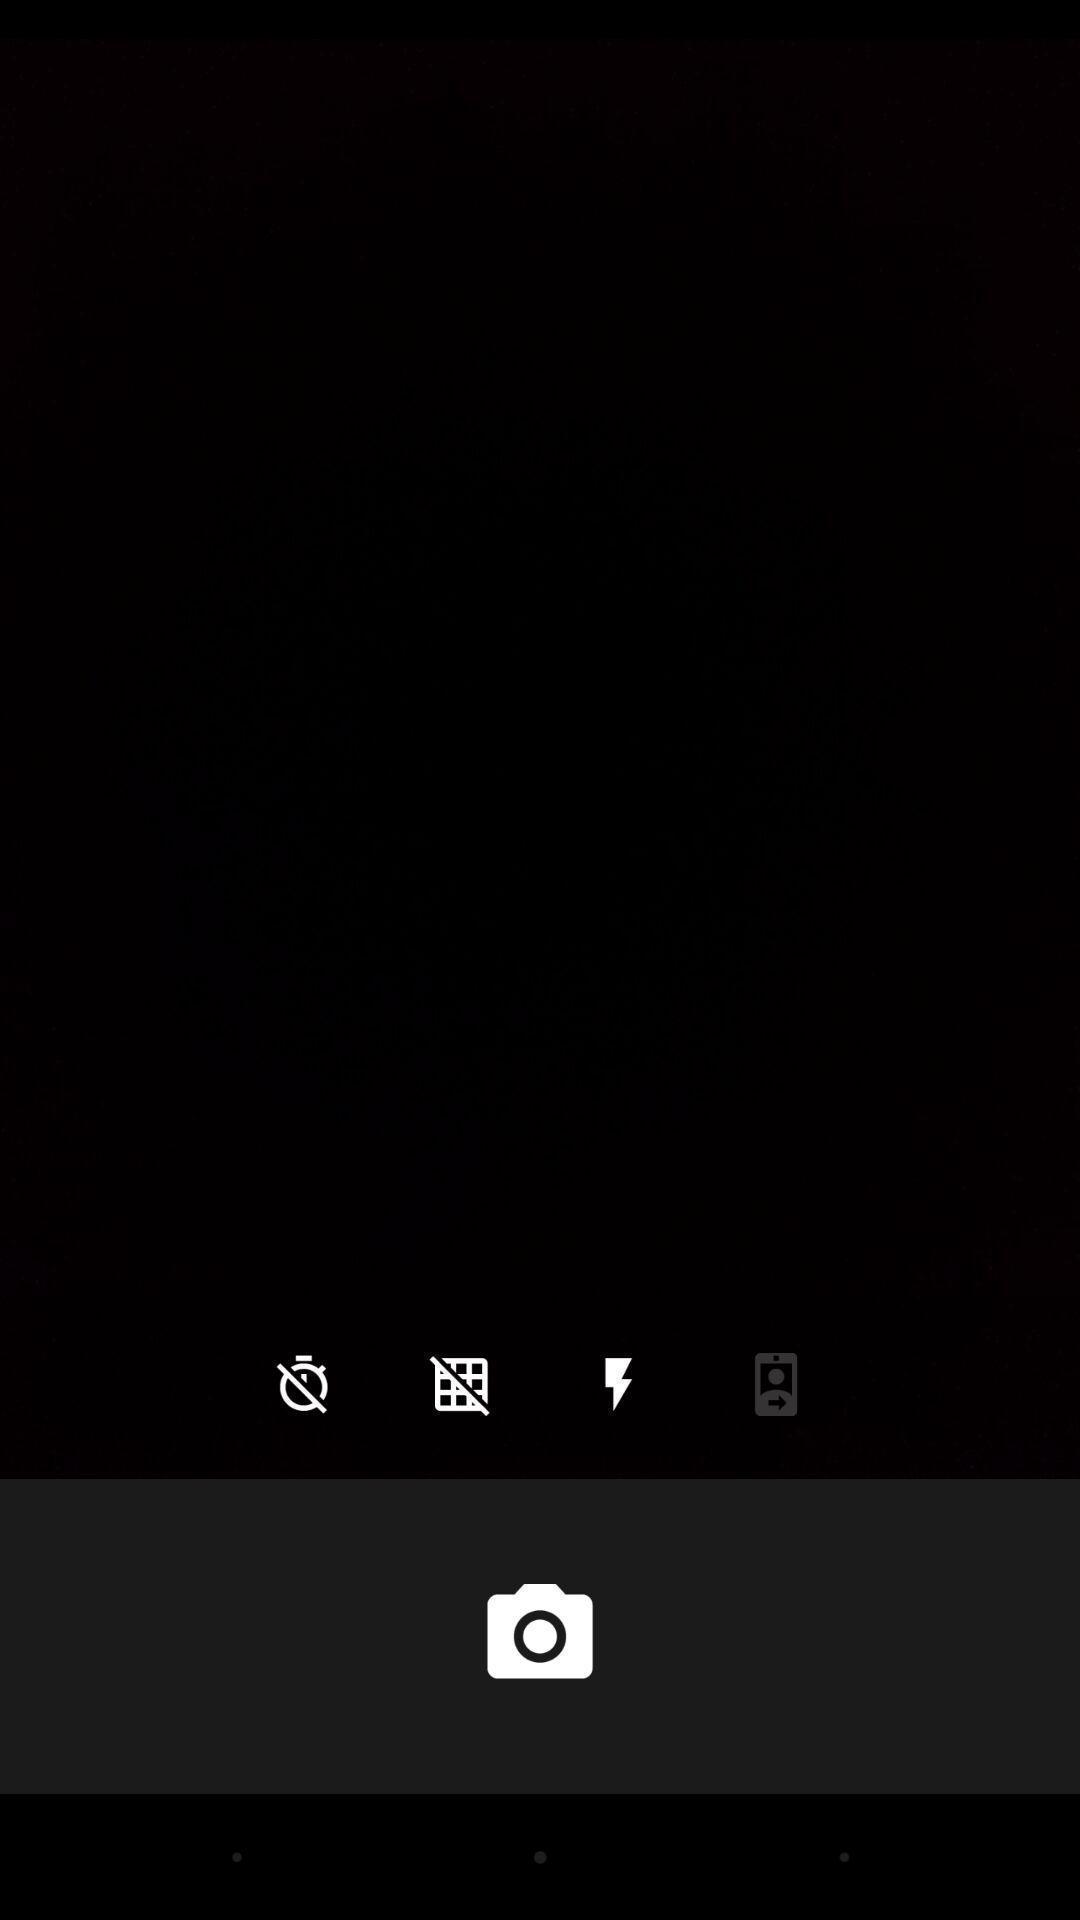Give me a narrative description of this picture. Screen shows a blank camera page. 